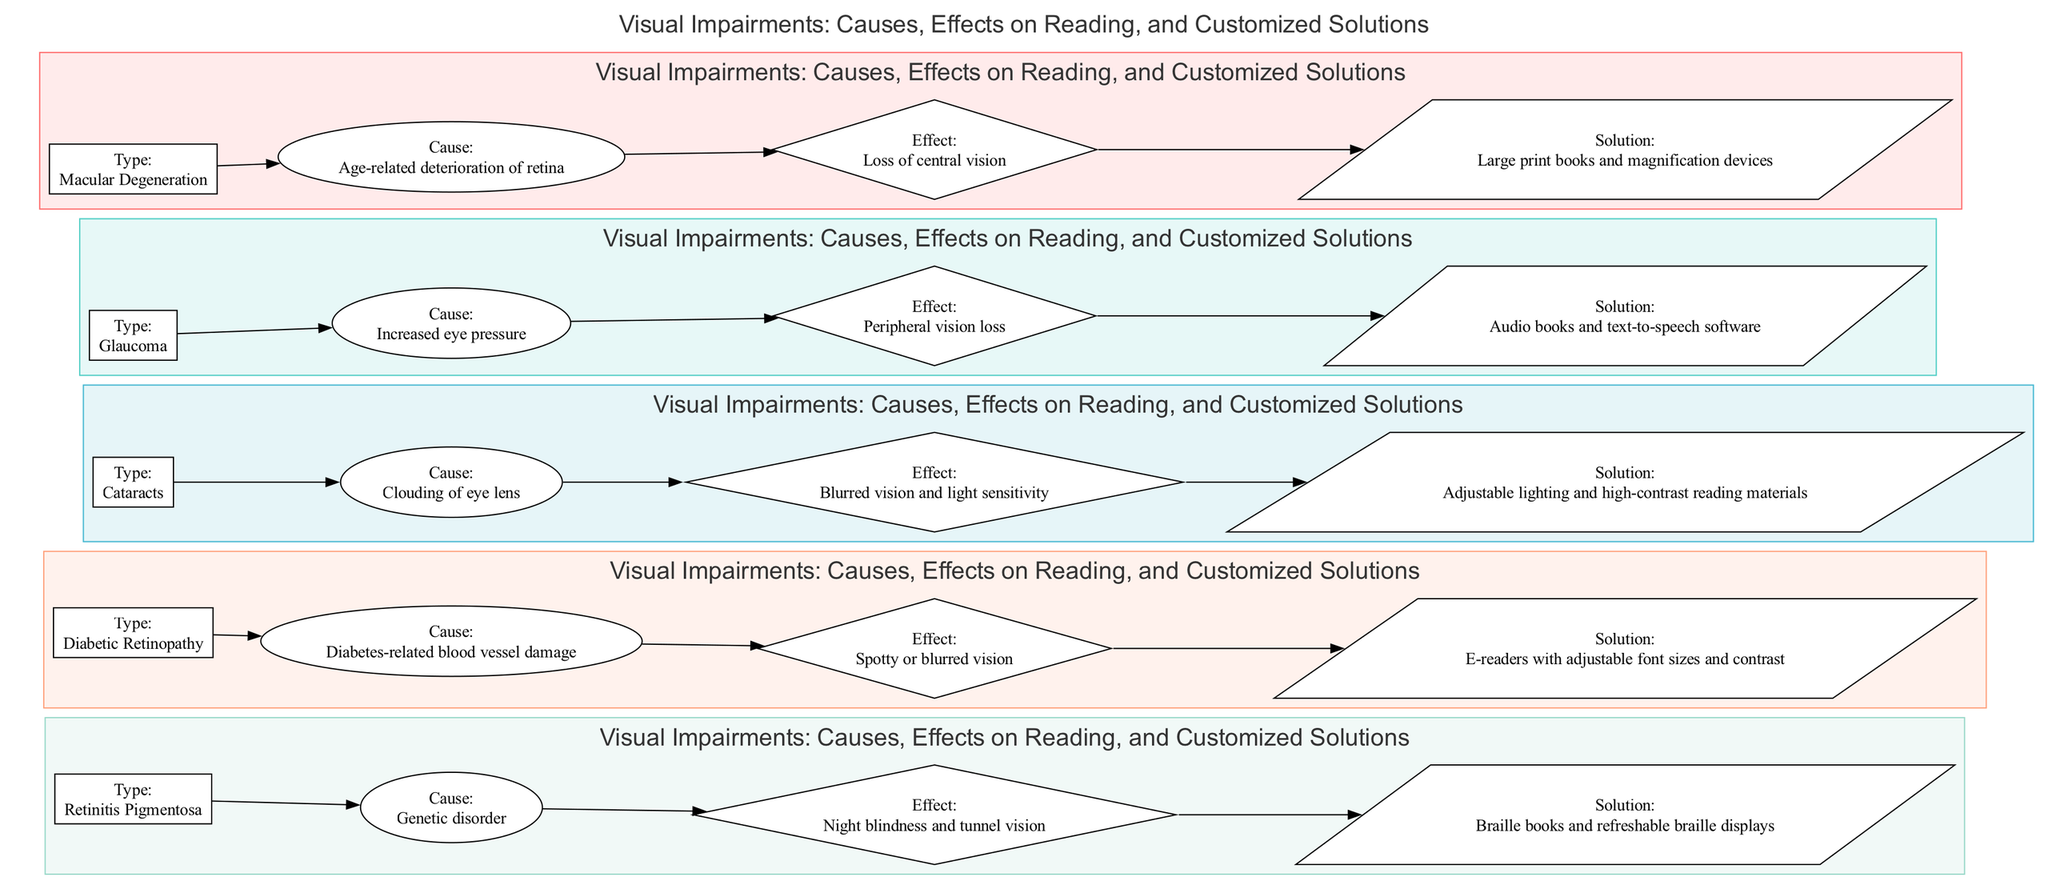What type of visual impairment causes loss of central vision? By looking at the diagram, I can locate the node labeled "Type:" and trace it to find the corresponding effect described. The impairment with the effect "Loss of central vision" is "Macular Degeneration."
Answer: Macular Degeneration Which solution is suggested for glaucoma? I examine the node corresponding to glaucoma in the diagram, and look at its connected solution node, which reads "Audio books and text-to-speech software."
Answer: Audio books and text-to-speech software How many different types of visual impairments are listed in the diagram? I can simply count the main impairment nodes present in the diagram. There are five distinct types listed.
Answer: 5 Which impairment is associated with adjustable lighting as a solution? I can identify the "Solution:" node related to cataracts, which states "Adjustable lighting and high-contrast reading materials." Hence, the impairment associated with this solution is "Cataracts."
Answer: Cataracts What is the cause of Diabetic Retinopathy? By locating the node for Diabetic Retinopathy, I observe the connected "Cause:" node, which indicates "Diabetes-related blood vessel damage."
Answer: Diabetes-related blood vessel damage Which visual impairment is linked to night blindness? I refer to the node for Retinitis Pigmentosa within the diagram. The effect of this impairment clearly indicates "Night blindness," establishing the relationship.
Answer: Retinitis Pigmentosa What effect is associated with cataracts? I find the node for cataracts in the diagram and examine the connected "Effect:" node, which states "Blurred vision and light sensitivity."
Answer: Blurred vision and light sensitivity Which visual impairment has peripheral vision loss as its effect? I can examine the diagram and find which impairment lists "Peripheral vision loss" as an effect, which is directly linked to the "Glaucoma" node.
Answer: Glaucoma What is the suggested reading solution for Macular Degeneration? Checking the node for Macular Degeneration, I can see that the recommended solution connected to it is "Large print books and magnification devices."
Answer: Large print books and magnification devices 